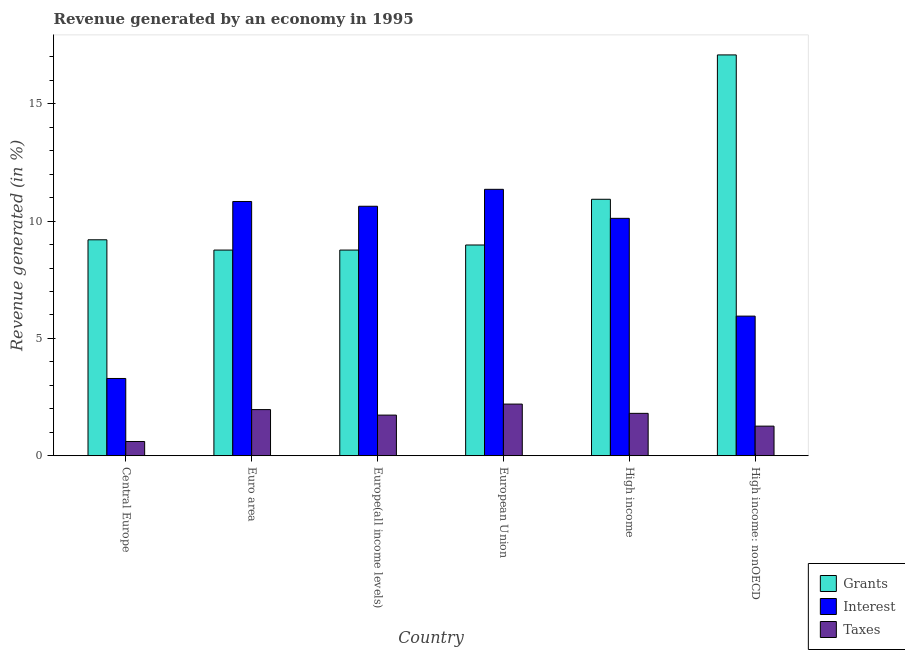How many groups of bars are there?
Provide a succinct answer. 6. Are the number of bars per tick equal to the number of legend labels?
Your answer should be compact. Yes. How many bars are there on the 3rd tick from the left?
Provide a short and direct response. 3. How many bars are there on the 2nd tick from the right?
Ensure brevity in your answer.  3. What is the label of the 1st group of bars from the left?
Your answer should be very brief. Central Europe. What is the percentage of revenue generated by taxes in Euro area?
Keep it short and to the point. 1.97. Across all countries, what is the maximum percentage of revenue generated by grants?
Ensure brevity in your answer.  17.08. Across all countries, what is the minimum percentage of revenue generated by taxes?
Provide a succinct answer. 0.61. In which country was the percentage of revenue generated by taxes minimum?
Provide a succinct answer. Central Europe. What is the total percentage of revenue generated by grants in the graph?
Your answer should be very brief. 63.73. What is the difference between the percentage of revenue generated by grants in Euro area and that in High income?
Your answer should be compact. -2.16. What is the difference between the percentage of revenue generated by grants in Europe(all income levels) and the percentage of revenue generated by taxes in High income?
Provide a short and direct response. 6.96. What is the average percentage of revenue generated by interest per country?
Offer a very short reply. 8.7. What is the difference between the percentage of revenue generated by grants and percentage of revenue generated by interest in Euro area?
Your answer should be very brief. -2.07. In how many countries, is the percentage of revenue generated by interest greater than 14 %?
Give a very brief answer. 0. What is the ratio of the percentage of revenue generated by interest in Euro area to that in High income: nonOECD?
Give a very brief answer. 1.82. Is the difference between the percentage of revenue generated by interest in Central Europe and High income: nonOECD greater than the difference between the percentage of revenue generated by taxes in Central Europe and High income: nonOECD?
Your answer should be very brief. No. What is the difference between the highest and the second highest percentage of revenue generated by interest?
Give a very brief answer. 0.52. What is the difference between the highest and the lowest percentage of revenue generated by grants?
Your response must be concise. 8.32. Is the sum of the percentage of revenue generated by taxes in Euro area and Europe(all income levels) greater than the maximum percentage of revenue generated by interest across all countries?
Keep it short and to the point. No. What does the 1st bar from the left in High income represents?
Offer a very short reply. Grants. What does the 1st bar from the right in Euro area represents?
Ensure brevity in your answer.  Taxes. How many countries are there in the graph?
Make the answer very short. 6. What is the difference between two consecutive major ticks on the Y-axis?
Your answer should be very brief. 5. Does the graph contain grids?
Your answer should be compact. No. How are the legend labels stacked?
Your response must be concise. Vertical. What is the title of the graph?
Provide a succinct answer. Revenue generated by an economy in 1995. What is the label or title of the Y-axis?
Ensure brevity in your answer.  Revenue generated (in %). What is the Revenue generated (in %) of Grants in Central Europe?
Your answer should be very brief. 9.2. What is the Revenue generated (in %) in Interest in Central Europe?
Your response must be concise. 3.29. What is the Revenue generated (in %) in Taxes in Central Europe?
Your answer should be compact. 0.61. What is the Revenue generated (in %) in Grants in Euro area?
Make the answer very short. 8.77. What is the Revenue generated (in %) in Interest in Euro area?
Ensure brevity in your answer.  10.84. What is the Revenue generated (in %) of Taxes in Euro area?
Offer a very short reply. 1.97. What is the Revenue generated (in %) of Grants in Europe(all income levels)?
Ensure brevity in your answer.  8.77. What is the Revenue generated (in %) in Interest in Europe(all income levels)?
Give a very brief answer. 10.63. What is the Revenue generated (in %) of Taxes in Europe(all income levels)?
Ensure brevity in your answer.  1.73. What is the Revenue generated (in %) of Grants in European Union?
Your answer should be very brief. 8.98. What is the Revenue generated (in %) in Interest in European Union?
Offer a terse response. 11.35. What is the Revenue generated (in %) of Taxes in European Union?
Make the answer very short. 2.2. What is the Revenue generated (in %) in Grants in High income?
Your response must be concise. 10.93. What is the Revenue generated (in %) in Interest in High income?
Offer a very short reply. 10.12. What is the Revenue generated (in %) of Taxes in High income?
Ensure brevity in your answer.  1.81. What is the Revenue generated (in %) in Grants in High income: nonOECD?
Your answer should be compact. 17.08. What is the Revenue generated (in %) of Interest in High income: nonOECD?
Ensure brevity in your answer.  5.95. What is the Revenue generated (in %) in Taxes in High income: nonOECD?
Make the answer very short. 1.26. Across all countries, what is the maximum Revenue generated (in %) of Grants?
Ensure brevity in your answer.  17.08. Across all countries, what is the maximum Revenue generated (in %) in Interest?
Your response must be concise. 11.35. Across all countries, what is the maximum Revenue generated (in %) of Taxes?
Make the answer very short. 2.2. Across all countries, what is the minimum Revenue generated (in %) of Grants?
Offer a terse response. 8.77. Across all countries, what is the minimum Revenue generated (in %) in Interest?
Ensure brevity in your answer.  3.29. Across all countries, what is the minimum Revenue generated (in %) in Taxes?
Ensure brevity in your answer.  0.61. What is the total Revenue generated (in %) in Grants in the graph?
Your answer should be very brief. 63.73. What is the total Revenue generated (in %) of Interest in the graph?
Give a very brief answer. 52.18. What is the total Revenue generated (in %) of Taxes in the graph?
Provide a succinct answer. 9.57. What is the difference between the Revenue generated (in %) of Grants in Central Europe and that in Euro area?
Your answer should be compact. 0.44. What is the difference between the Revenue generated (in %) of Interest in Central Europe and that in Euro area?
Offer a terse response. -7.54. What is the difference between the Revenue generated (in %) in Taxes in Central Europe and that in Euro area?
Offer a very short reply. -1.36. What is the difference between the Revenue generated (in %) in Grants in Central Europe and that in Europe(all income levels)?
Your response must be concise. 0.44. What is the difference between the Revenue generated (in %) of Interest in Central Europe and that in Europe(all income levels)?
Provide a short and direct response. -7.34. What is the difference between the Revenue generated (in %) of Taxes in Central Europe and that in Europe(all income levels)?
Your response must be concise. -1.13. What is the difference between the Revenue generated (in %) of Grants in Central Europe and that in European Union?
Give a very brief answer. 0.22. What is the difference between the Revenue generated (in %) of Interest in Central Europe and that in European Union?
Your answer should be very brief. -8.06. What is the difference between the Revenue generated (in %) in Taxes in Central Europe and that in European Union?
Your response must be concise. -1.59. What is the difference between the Revenue generated (in %) in Grants in Central Europe and that in High income?
Offer a very short reply. -1.73. What is the difference between the Revenue generated (in %) of Interest in Central Europe and that in High income?
Make the answer very short. -6.83. What is the difference between the Revenue generated (in %) in Taxes in Central Europe and that in High income?
Make the answer very short. -1.2. What is the difference between the Revenue generated (in %) of Grants in Central Europe and that in High income: nonOECD?
Offer a terse response. -7.88. What is the difference between the Revenue generated (in %) of Interest in Central Europe and that in High income: nonOECD?
Give a very brief answer. -2.66. What is the difference between the Revenue generated (in %) in Taxes in Central Europe and that in High income: nonOECD?
Make the answer very short. -0.65. What is the difference between the Revenue generated (in %) in Interest in Euro area and that in Europe(all income levels)?
Your answer should be compact. 0.2. What is the difference between the Revenue generated (in %) of Taxes in Euro area and that in Europe(all income levels)?
Give a very brief answer. 0.23. What is the difference between the Revenue generated (in %) in Grants in Euro area and that in European Union?
Your answer should be very brief. -0.22. What is the difference between the Revenue generated (in %) of Interest in Euro area and that in European Union?
Offer a terse response. -0.52. What is the difference between the Revenue generated (in %) in Taxes in Euro area and that in European Union?
Offer a terse response. -0.23. What is the difference between the Revenue generated (in %) of Grants in Euro area and that in High income?
Provide a succinct answer. -2.17. What is the difference between the Revenue generated (in %) of Interest in Euro area and that in High income?
Ensure brevity in your answer.  0.72. What is the difference between the Revenue generated (in %) of Taxes in Euro area and that in High income?
Ensure brevity in your answer.  0.16. What is the difference between the Revenue generated (in %) of Grants in Euro area and that in High income: nonOECD?
Keep it short and to the point. -8.32. What is the difference between the Revenue generated (in %) in Interest in Euro area and that in High income: nonOECD?
Keep it short and to the point. 4.89. What is the difference between the Revenue generated (in %) of Taxes in Euro area and that in High income: nonOECD?
Your response must be concise. 0.7. What is the difference between the Revenue generated (in %) in Grants in Europe(all income levels) and that in European Union?
Make the answer very short. -0.22. What is the difference between the Revenue generated (in %) in Interest in Europe(all income levels) and that in European Union?
Make the answer very short. -0.72. What is the difference between the Revenue generated (in %) in Taxes in Europe(all income levels) and that in European Union?
Make the answer very short. -0.47. What is the difference between the Revenue generated (in %) in Grants in Europe(all income levels) and that in High income?
Keep it short and to the point. -2.17. What is the difference between the Revenue generated (in %) of Interest in Europe(all income levels) and that in High income?
Your answer should be very brief. 0.51. What is the difference between the Revenue generated (in %) of Taxes in Europe(all income levels) and that in High income?
Provide a succinct answer. -0.07. What is the difference between the Revenue generated (in %) in Grants in Europe(all income levels) and that in High income: nonOECD?
Make the answer very short. -8.32. What is the difference between the Revenue generated (in %) of Interest in Europe(all income levels) and that in High income: nonOECD?
Provide a short and direct response. 4.68. What is the difference between the Revenue generated (in %) of Taxes in Europe(all income levels) and that in High income: nonOECD?
Ensure brevity in your answer.  0.47. What is the difference between the Revenue generated (in %) of Grants in European Union and that in High income?
Ensure brevity in your answer.  -1.95. What is the difference between the Revenue generated (in %) in Interest in European Union and that in High income?
Your answer should be very brief. 1.24. What is the difference between the Revenue generated (in %) of Taxes in European Union and that in High income?
Give a very brief answer. 0.39. What is the difference between the Revenue generated (in %) of Grants in European Union and that in High income: nonOECD?
Your answer should be very brief. -8.1. What is the difference between the Revenue generated (in %) in Interest in European Union and that in High income: nonOECD?
Ensure brevity in your answer.  5.4. What is the difference between the Revenue generated (in %) of Taxes in European Union and that in High income: nonOECD?
Offer a terse response. 0.94. What is the difference between the Revenue generated (in %) in Grants in High income and that in High income: nonOECD?
Your answer should be compact. -6.15. What is the difference between the Revenue generated (in %) in Interest in High income and that in High income: nonOECD?
Give a very brief answer. 4.17. What is the difference between the Revenue generated (in %) of Taxes in High income and that in High income: nonOECD?
Give a very brief answer. 0.55. What is the difference between the Revenue generated (in %) of Grants in Central Europe and the Revenue generated (in %) of Interest in Euro area?
Your answer should be very brief. -1.63. What is the difference between the Revenue generated (in %) of Grants in Central Europe and the Revenue generated (in %) of Taxes in Euro area?
Provide a short and direct response. 7.24. What is the difference between the Revenue generated (in %) of Interest in Central Europe and the Revenue generated (in %) of Taxes in Euro area?
Your answer should be compact. 1.33. What is the difference between the Revenue generated (in %) of Grants in Central Europe and the Revenue generated (in %) of Interest in Europe(all income levels)?
Offer a very short reply. -1.43. What is the difference between the Revenue generated (in %) in Grants in Central Europe and the Revenue generated (in %) in Taxes in Europe(all income levels)?
Provide a short and direct response. 7.47. What is the difference between the Revenue generated (in %) of Interest in Central Europe and the Revenue generated (in %) of Taxes in Europe(all income levels)?
Your answer should be compact. 1.56. What is the difference between the Revenue generated (in %) of Grants in Central Europe and the Revenue generated (in %) of Interest in European Union?
Your answer should be very brief. -2.15. What is the difference between the Revenue generated (in %) of Grants in Central Europe and the Revenue generated (in %) of Taxes in European Union?
Offer a very short reply. 7. What is the difference between the Revenue generated (in %) of Interest in Central Europe and the Revenue generated (in %) of Taxes in European Union?
Your answer should be very brief. 1.09. What is the difference between the Revenue generated (in %) of Grants in Central Europe and the Revenue generated (in %) of Interest in High income?
Provide a succinct answer. -0.91. What is the difference between the Revenue generated (in %) in Grants in Central Europe and the Revenue generated (in %) in Taxes in High income?
Your response must be concise. 7.4. What is the difference between the Revenue generated (in %) in Interest in Central Europe and the Revenue generated (in %) in Taxes in High income?
Make the answer very short. 1.49. What is the difference between the Revenue generated (in %) of Grants in Central Europe and the Revenue generated (in %) of Interest in High income: nonOECD?
Your answer should be compact. 3.25. What is the difference between the Revenue generated (in %) of Grants in Central Europe and the Revenue generated (in %) of Taxes in High income: nonOECD?
Your response must be concise. 7.94. What is the difference between the Revenue generated (in %) in Interest in Central Europe and the Revenue generated (in %) in Taxes in High income: nonOECD?
Your response must be concise. 2.03. What is the difference between the Revenue generated (in %) of Grants in Euro area and the Revenue generated (in %) of Interest in Europe(all income levels)?
Your response must be concise. -1.87. What is the difference between the Revenue generated (in %) in Grants in Euro area and the Revenue generated (in %) in Taxes in Europe(all income levels)?
Ensure brevity in your answer.  7.03. What is the difference between the Revenue generated (in %) of Interest in Euro area and the Revenue generated (in %) of Taxes in Europe(all income levels)?
Your answer should be very brief. 9.1. What is the difference between the Revenue generated (in %) of Grants in Euro area and the Revenue generated (in %) of Interest in European Union?
Your answer should be compact. -2.59. What is the difference between the Revenue generated (in %) in Grants in Euro area and the Revenue generated (in %) in Taxes in European Union?
Keep it short and to the point. 6.56. What is the difference between the Revenue generated (in %) in Interest in Euro area and the Revenue generated (in %) in Taxes in European Union?
Your answer should be very brief. 8.63. What is the difference between the Revenue generated (in %) in Grants in Euro area and the Revenue generated (in %) in Interest in High income?
Make the answer very short. -1.35. What is the difference between the Revenue generated (in %) in Grants in Euro area and the Revenue generated (in %) in Taxes in High income?
Offer a very short reply. 6.96. What is the difference between the Revenue generated (in %) in Interest in Euro area and the Revenue generated (in %) in Taxes in High income?
Keep it short and to the point. 9.03. What is the difference between the Revenue generated (in %) of Grants in Euro area and the Revenue generated (in %) of Interest in High income: nonOECD?
Provide a short and direct response. 2.81. What is the difference between the Revenue generated (in %) in Grants in Euro area and the Revenue generated (in %) in Taxes in High income: nonOECD?
Ensure brevity in your answer.  7.5. What is the difference between the Revenue generated (in %) of Interest in Euro area and the Revenue generated (in %) of Taxes in High income: nonOECD?
Make the answer very short. 9.57. What is the difference between the Revenue generated (in %) in Grants in Europe(all income levels) and the Revenue generated (in %) in Interest in European Union?
Ensure brevity in your answer.  -2.59. What is the difference between the Revenue generated (in %) of Grants in Europe(all income levels) and the Revenue generated (in %) of Taxes in European Union?
Make the answer very short. 6.56. What is the difference between the Revenue generated (in %) in Interest in Europe(all income levels) and the Revenue generated (in %) in Taxes in European Union?
Ensure brevity in your answer.  8.43. What is the difference between the Revenue generated (in %) of Grants in Europe(all income levels) and the Revenue generated (in %) of Interest in High income?
Ensure brevity in your answer.  -1.35. What is the difference between the Revenue generated (in %) of Grants in Europe(all income levels) and the Revenue generated (in %) of Taxes in High income?
Your response must be concise. 6.96. What is the difference between the Revenue generated (in %) of Interest in Europe(all income levels) and the Revenue generated (in %) of Taxes in High income?
Make the answer very short. 8.83. What is the difference between the Revenue generated (in %) of Grants in Europe(all income levels) and the Revenue generated (in %) of Interest in High income: nonOECD?
Make the answer very short. 2.81. What is the difference between the Revenue generated (in %) in Grants in Europe(all income levels) and the Revenue generated (in %) in Taxes in High income: nonOECD?
Your response must be concise. 7.5. What is the difference between the Revenue generated (in %) in Interest in Europe(all income levels) and the Revenue generated (in %) in Taxes in High income: nonOECD?
Provide a short and direct response. 9.37. What is the difference between the Revenue generated (in %) in Grants in European Union and the Revenue generated (in %) in Interest in High income?
Make the answer very short. -1.14. What is the difference between the Revenue generated (in %) in Grants in European Union and the Revenue generated (in %) in Taxes in High income?
Offer a very short reply. 7.17. What is the difference between the Revenue generated (in %) of Interest in European Union and the Revenue generated (in %) of Taxes in High income?
Provide a succinct answer. 9.55. What is the difference between the Revenue generated (in %) in Grants in European Union and the Revenue generated (in %) in Interest in High income: nonOECD?
Your answer should be compact. 3.03. What is the difference between the Revenue generated (in %) in Grants in European Union and the Revenue generated (in %) in Taxes in High income: nonOECD?
Give a very brief answer. 7.72. What is the difference between the Revenue generated (in %) in Interest in European Union and the Revenue generated (in %) in Taxes in High income: nonOECD?
Ensure brevity in your answer.  10.09. What is the difference between the Revenue generated (in %) of Grants in High income and the Revenue generated (in %) of Interest in High income: nonOECD?
Offer a very short reply. 4.98. What is the difference between the Revenue generated (in %) of Grants in High income and the Revenue generated (in %) of Taxes in High income: nonOECD?
Offer a terse response. 9.67. What is the difference between the Revenue generated (in %) of Interest in High income and the Revenue generated (in %) of Taxes in High income: nonOECD?
Provide a short and direct response. 8.86. What is the average Revenue generated (in %) in Grants per country?
Give a very brief answer. 10.62. What is the average Revenue generated (in %) of Interest per country?
Your answer should be compact. 8.7. What is the average Revenue generated (in %) in Taxes per country?
Keep it short and to the point. 1.6. What is the difference between the Revenue generated (in %) in Grants and Revenue generated (in %) in Interest in Central Europe?
Make the answer very short. 5.91. What is the difference between the Revenue generated (in %) in Grants and Revenue generated (in %) in Taxes in Central Europe?
Your answer should be very brief. 8.6. What is the difference between the Revenue generated (in %) in Interest and Revenue generated (in %) in Taxes in Central Europe?
Keep it short and to the point. 2.69. What is the difference between the Revenue generated (in %) of Grants and Revenue generated (in %) of Interest in Euro area?
Ensure brevity in your answer.  -2.07. What is the difference between the Revenue generated (in %) of Grants and Revenue generated (in %) of Taxes in Euro area?
Your answer should be compact. 6.8. What is the difference between the Revenue generated (in %) in Interest and Revenue generated (in %) in Taxes in Euro area?
Offer a very short reply. 8.87. What is the difference between the Revenue generated (in %) of Grants and Revenue generated (in %) of Interest in Europe(all income levels)?
Your response must be concise. -1.87. What is the difference between the Revenue generated (in %) of Grants and Revenue generated (in %) of Taxes in Europe(all income levels)?
Provide a succinct answer. 7.03. What is the difference between the Revenue generated (in %) in Interest and Revenue generated (in %) in Taxes in Europe(all income levels)?
Provide a short and direct response. 8.9. What is the difference between the Revenue generated (in %) in Grants and Revenue generated (in %) in Interest in European Union?
Keep it short and to the point. -2.37. What is the difference between the Revenue generated (in %) in Grants and Revenue generated (in %) in Taxes in European Union?
Provide a short and direct response. 6.78. What is the difference between the Revenue generated (in %) in Interest and Revenue generated (in %) in Taxes in European Union?
Give a very brief answer. 9.15. What is the difference between the Revenue generated (in %) of Grants and Revenue generated (in %) of Interest in High income?
Your response must be concise. 0.81. What is the difference between the Revenue generated (in %) of Grants and Revenue generated (in %) of Taxes in High income?
Provide a short and direct response. 9.12. What is the difference between the Revenue generated (in %) of Interest and Revenue generated (in %) of Taxes in High income?
Your answer should be compact. 8.31. What is the difference between the Revenue generated (in %) of Grants and Revenue generated (in %) of Interest in High income: nonOECD?
Provide a short and direct response. 11.13. What is the difference between the Revenue generated (in %) in Grants and Revenue generated (in %) in Taxes in High income: nonOECD?
Your answer should be compact. 15.82. What is the difference between the Revenue generated (in %) of Interest and Revenue generated (in %) of Taxes in High income: nonOECD?
Keep it short and to the point. 4.69. What is the ratio of the Revenue generated (in %) of Interest in Central Europe to that in Euro area?
Provide a succinct answer. 0.3. What is the ratio of the Revenue generated (in %) of Taxes in Central Europe to that in Euro area?
Offer a very short reply. 0.31. What is the ratio of the Revenue generated (in %) of Grants in Central Europe to that in Europe(all income levels)?
Your response must be concise. 1.05. What is the ratio of the Revenue generated (in %) of Interest in Central Europe to that in Europe(all income levels)?
Offer a very short reply. 0.31. What is the ratio of the Revenue generated (in %) in Taxes in Central Europe to that in Europe(all income levels)?
Your response must be concise. 0.35. What is the ratio of the Revenue generated (in %) in Grants in Central Europe to that in European Union?
Provide a succinct answer. 1.02. What is the ratio of the Revenue generated (in %) of Interest in Central Europe to that in European Union?
Keep it short and to the point. 0.29. What is the ratio of the Revenue generated (in %) in Taxes in Central Europe to that in European Union?
Offer a terse response. 0.28. What is the ratio of the Revenue generated (in %) of Grants in Central Europe to that in High income?
Offer a terse response. 0.84. What is the ratio of the Revenue generated (in %) in Interest in Central Europe to that in High income?
Make the answer very short. 0.33. What is the ratio of the Revenue generated (in %) in Taxes in Central Europe to that in High income?
Offer a terse response. 0.34. What is the ratio of the Revenue generated (in %) in Grants in Central Europe to that in High income: nonOECD?
Provide a short and direct response. 0.54. What is the ratio of the Revenue generated (in %) in Interest in Central Europe to that in High income: nonOECD?
Give a very brief answer. 0.55. What is the ratio of the Revenue generated (in %) in Taxes in Central Europe to that in High income: nonOECD?
Provide a short and direct response. 0.48. What is the ratio of the Revenue generated (in %) of Grants in Euro area to that in Europe(all income levels)?
Offer a terse response. 1. What is the ratio of the Revenue generated (in %) in Interest in Euro area to that in Europe(all income levels)?
Keep it short and to the point. 1.02. What is the ratio of the Revenue generated (in %) in Taxes in Euro area to that in Europe(all income levels)?
Offer a very short reply. 1.14. What is the ratio of the Revenue generated (in %) in Grants in Euro area to that in European Union?
Give a very brief answer. 0.98. What is the ratio of the Revenue generated (in %) in Interest in Euro area to that in European Union?
Make the answer very short. 0.95. What is the ratio of the Revenue generated (in %) of Taxes in Euro area to that in European Union?
Provide a succinct answer. 0.89. What is the ratio of the Revenue generated (in %) of Grants in Euro area to that in High income?
Provide a short and direct response. 0.8. What is the ratio of the Revenue generated (in %) in Interest in Euro area to that in High income?
Your answer should be very brief. 1.07. What is the ratio of the Revenue generated (in %) in Taxes in Euro area to that in High income?
Provide a succinct answer. 1.09. What is the ratio of the Revenue generated (in %) of Grants in Euro area to that in High income: nonOECD?
Your answer should be compact. 0.51. What is the ratio of the Revenue generated (in %) of Interest in Euro area to that in High income: nonOECD?
Provide a succinct answer. 1.82. What is the ratio of the Revenue generated (in %) in Taxes in Euro area to that in High income: nonOECD?
Keep it short and to the point. 1.56. What is the ratio of the Revenue generated (in %) in Grants in Europe(all income levels) to that in European Union?
Provide a short and direct response. 0.98. What is the ratio of the Revenue generated (in %) of Interest in Europe(all income levels) to that in European Union?
Your response must be concise. 0.94. What is the ratio of the Revenue generated (in %) in Taxes in Europe(all income levels) to that in European Union?
Offer a terse response. 0.79. What is the ratio of the Revenue generated (in %) of Grants in Europe(all income levels) to that in High income?
Your answer should be very brief. 0.8. What is the ratio of the Revenue generated (in %) in Interest in Europe(all income levels) to that in High income?
Make the answer very short. 1.05. What is the ratio of the Revenue generated (in %) in Taxes in Europe(all income levels) to that in High income?
Give a very brief answer. 0.96. What is the ratio of the Revenue generated (in %) in Grants in Europe(all income levels) to that in High income: nonOECD?
Provide a succinct answer. 0.51. What is the ratio of the Revenue generated (in %) of Interest in Europe(all income levels) to that in High income: nonOECD?
Your response must be concise. 1.79. What is the ratio of the Revenue generated (in %) in Taxes in Europe(all income levels) to that in High income: nonOECD?
Your answer should be very brief. 1.37. What is the ratio of the Revenue generated (in %) in Grants in European Union to that in High income?
Your answer should be very brief. 0.82. What is the ratio of the Revenue generated (in %) of Interest in European Union to that in High income?
Your response must be concise. 1.12. What is the ratio of the Revenue generated (in %) in Taxes in European Union to that in High income?
Provide a short and direct response. 1.22. What is the ratio of the Revenue generated (in %) in Grants in European Union to that in High income: nonOECD?
Offer a very short reply. 0.53. What is the ratio of the Revenue generated (in %) of Interest in European Union to that in High income: nonOECD?
Offer a terse response. 1.91. What is the ratio of the Revenue generated (in %) of Taxes in European Union to that in High income: nonOECD?
Give a very brief answer. 1.75. What is the ratio of the Revenue generated (in %) in Grants in High income to that in High income: nonOECD?
Provide a short and direct response. 0.64. What is the ratio of the Revenue generated (in %) in Interest in High income to that in High income: nonOECD?
Your response must be concise. 1.7. What is the ratio of the Revenue generated (in %) in Taxes in High income to that in High income: nonOECD?
Keep it short and to the point. 1.43. What is the difference between the highest and the second highest Revenue generated (in %) of Grants?
Keep it short and to the point. 6.15. What is the difference between the highest and the second highest Revenue generated (in %) in Interest?
Offer a very short reply. 0.52. What is the difference between the highest and the second highest Revenue generated (in %) of Taxes?
Your answer should be compact. 0.23. What is the difference between the highest and the lowest Revenue generated (in %) in Grants?
Give a very brief answer. 8.32. What is the difference between the highest and the lowest Revenue generated (in %) of Interest?
Give a very brief answer. 8.06. What is the difference between the highest and the lowest Revenue generated (in %) of Taxes?
Provide a short and direct response. 1.59. 